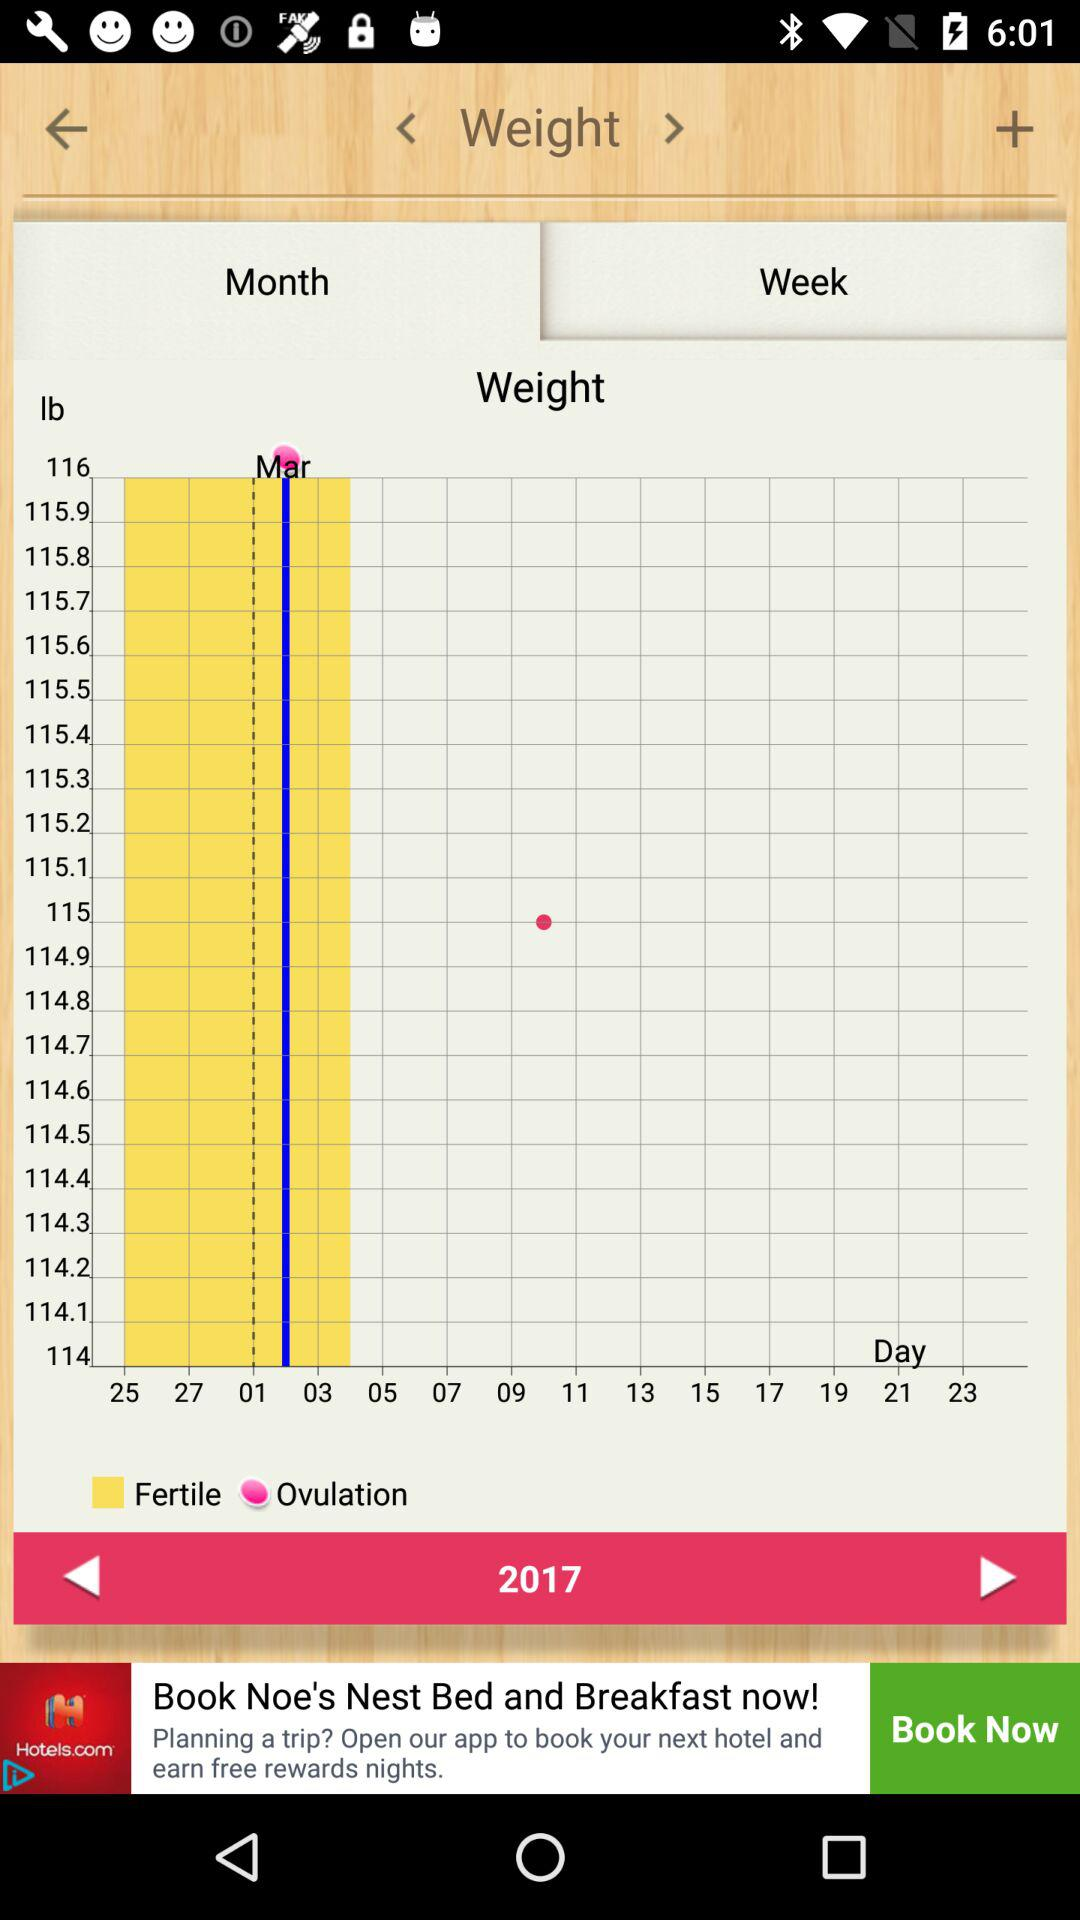Which option is selected in the "Weight"? The option that is selected in the "Weight" is "Week". 